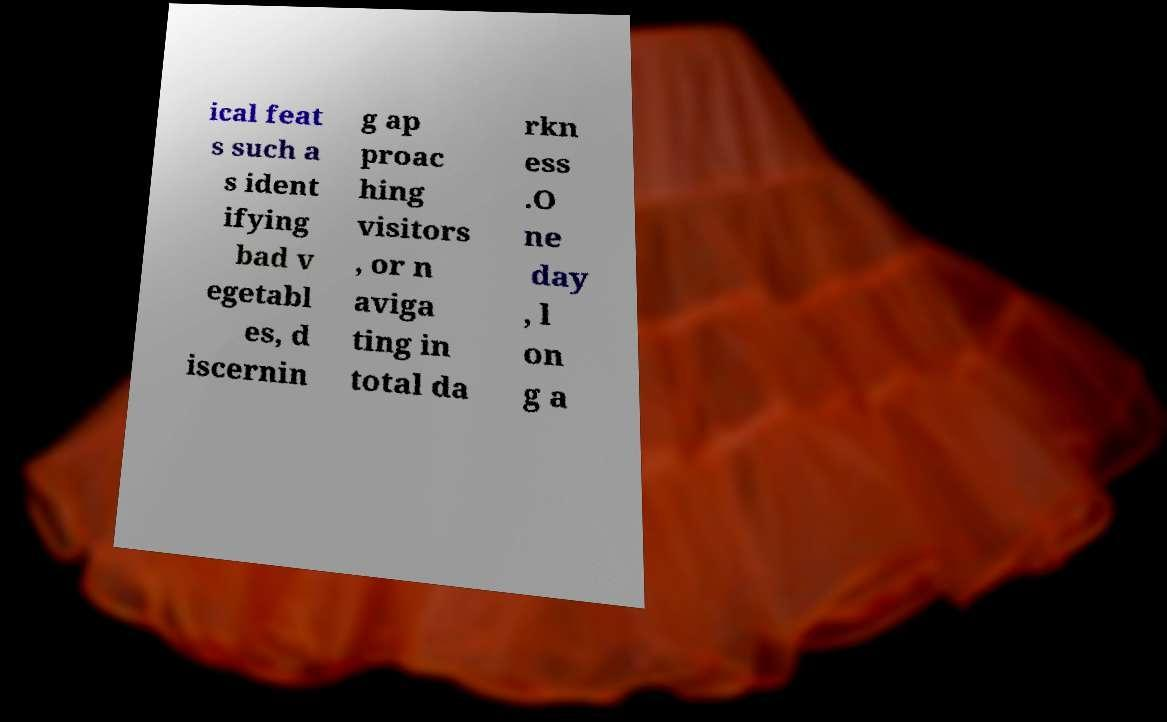Please read and relay the text visible in this image. What does it say? ical feat s such a s ident ifying bad v egetabl es, d iscernin g ap proac hing visitors , or n aviga ting in total da rkn ess .O ne day , l on g a 